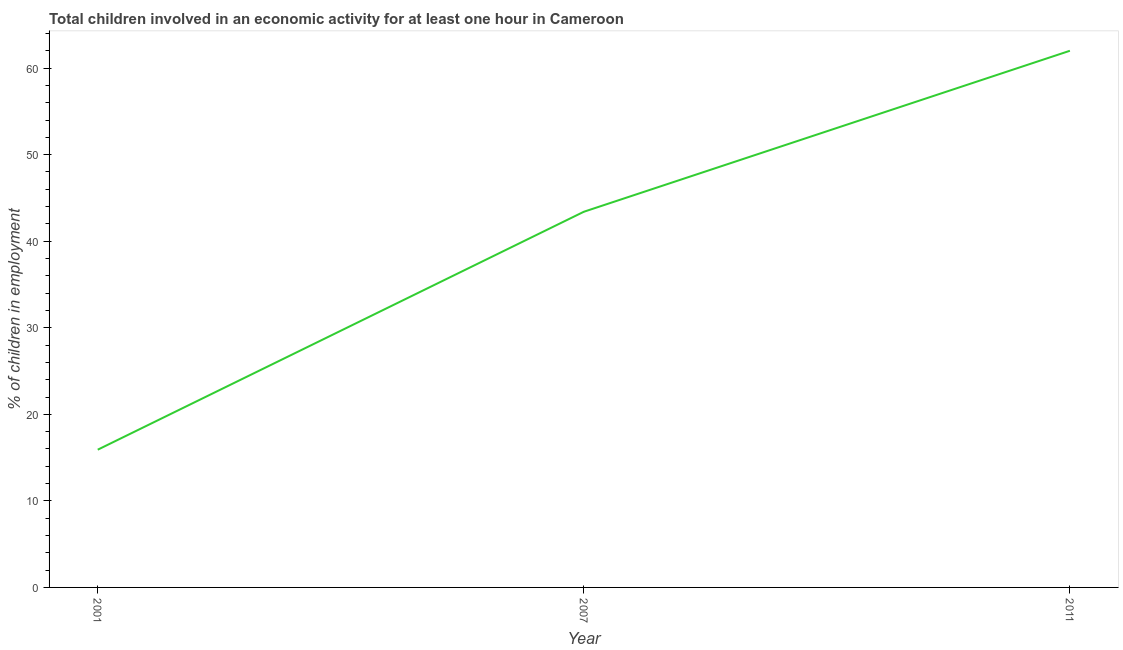Across all years, what is the minimum percentage of children in employment?
Your response must be concise. 15.91. In which year was the percentage of children in employment maximum?
Your answer should be very brief. 2011. What is the sum of the percentage of children in employment?
Ensure brevity in your answer.  121.31. What is the difference between the percentage of children in employment in 2001 and 2007?
Make the answer very short. -27.49. What is the average percentage of children in employment per year?
Your answer should be compact. 40.44. What is the median percentage of children in employment?
Offer a very short reply. 43.4. In how many years, is the percentage of children in employment greater than 44 %?
Ensure brevity in your answer.  1. Do a majority of the years between 2011 and 2007 (inclusive) have percentage of children in employment greater than 36 %?
Provide a succinct answer. No. What is the ratio of the percentage of children in employment in 2001 to that in 2011?
Your response must be concise. 0.26. Is the percentage of children in employment in 2001 less than that in 2007?
Keep it short and to the point. Yes. What is the difference between the highest and the second highest percentage of children in employment?
Provide a short and direct response. 18.6. What is the difference between the highest and the lowest percentage of children in employment?
Your answer should be compact. 46.09. In how many years, is the percentage of children in employment greater than the average percentage of children in employment taken over all years?
Give a very brief answer. 2. How many years are there in the graph?
Your answer should be very brief. 3. What is the title of the graph?
Your answer should be very brief. Total children involved in an economic activity for at least one hour in Cameroon. What is the label or title of the X-axis?
Offer a terse response. Year. What is the label or title of the Y-axis?
Keep it short and to the point. % of children in employment. What is the % of children in employment of 2001?
Your answer should be very brief. 15.91. What is the % of children in employment of 2007?
Make the answer very short. 43.4. What is the difference between the % of children in employment in 2001 and 2007?
Provide a succinct answer. -27.49. What is the difference between the % of children in employment in 2001 and 2011?
Your answer should be very brief. -46.09. What is the difference between the % of children in employment in 2007 and 2011?
Provide a succinct answer. -18.6. What is the ratio of the % of children in employment in 2001 to that in 2007?
Ensure brevity in your answer.  0.37. What is the ratio of the % of children in employment in 2001 to that in 2011?
Your answer should be very brief. 0.26. 